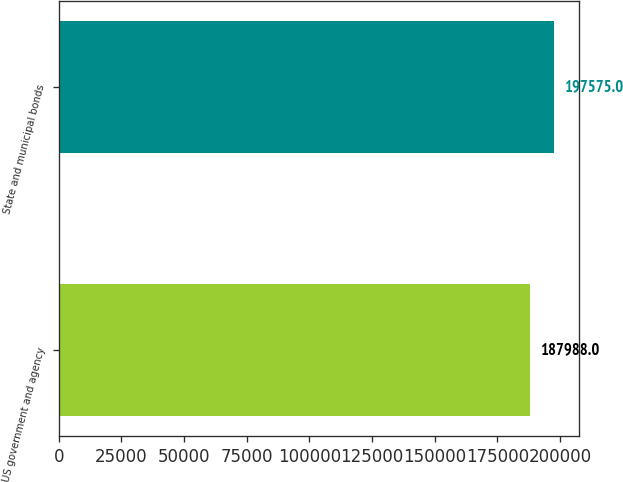Convert chart. <chart><loc_0><loc_0><loc_500><loc_500><bar_chart><fcel>US government and agency<fcel>State and municipal bonds<nl><fcel>187988<fcel>197575<nl></chart> 